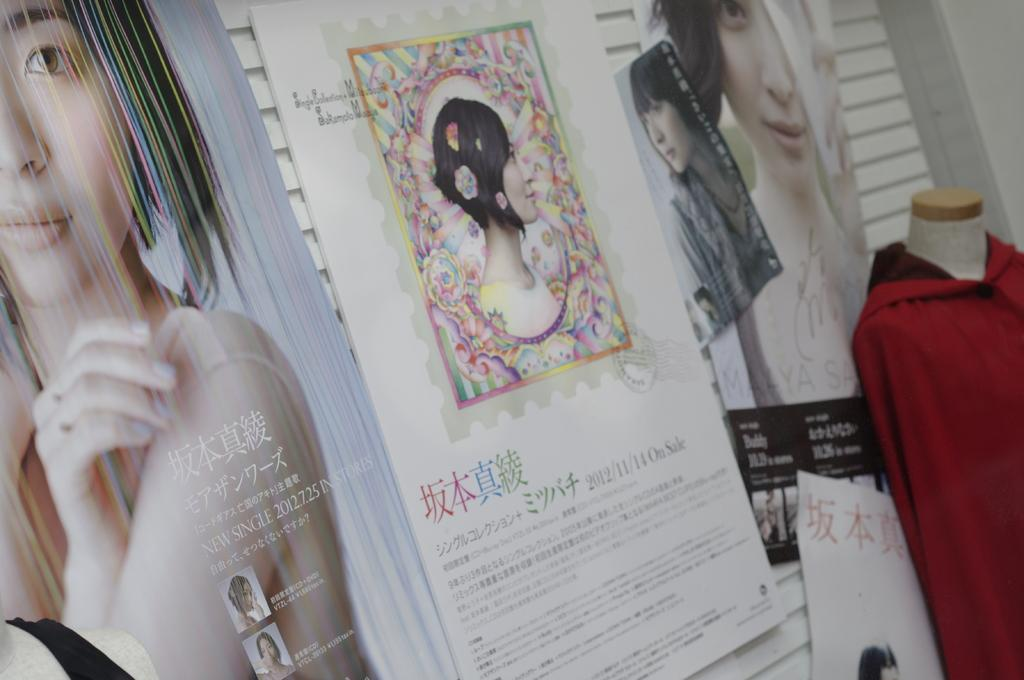What is displayed on the mannequin in the image? There is a dress on a mannequin in the image. What can be seen on the walls in the image? There are advertisement boards on the walls in the image. What type of government is depicted on the dress in the image? There is no government depicted on the dress in the image; it is simply a dress on a mannequin. 